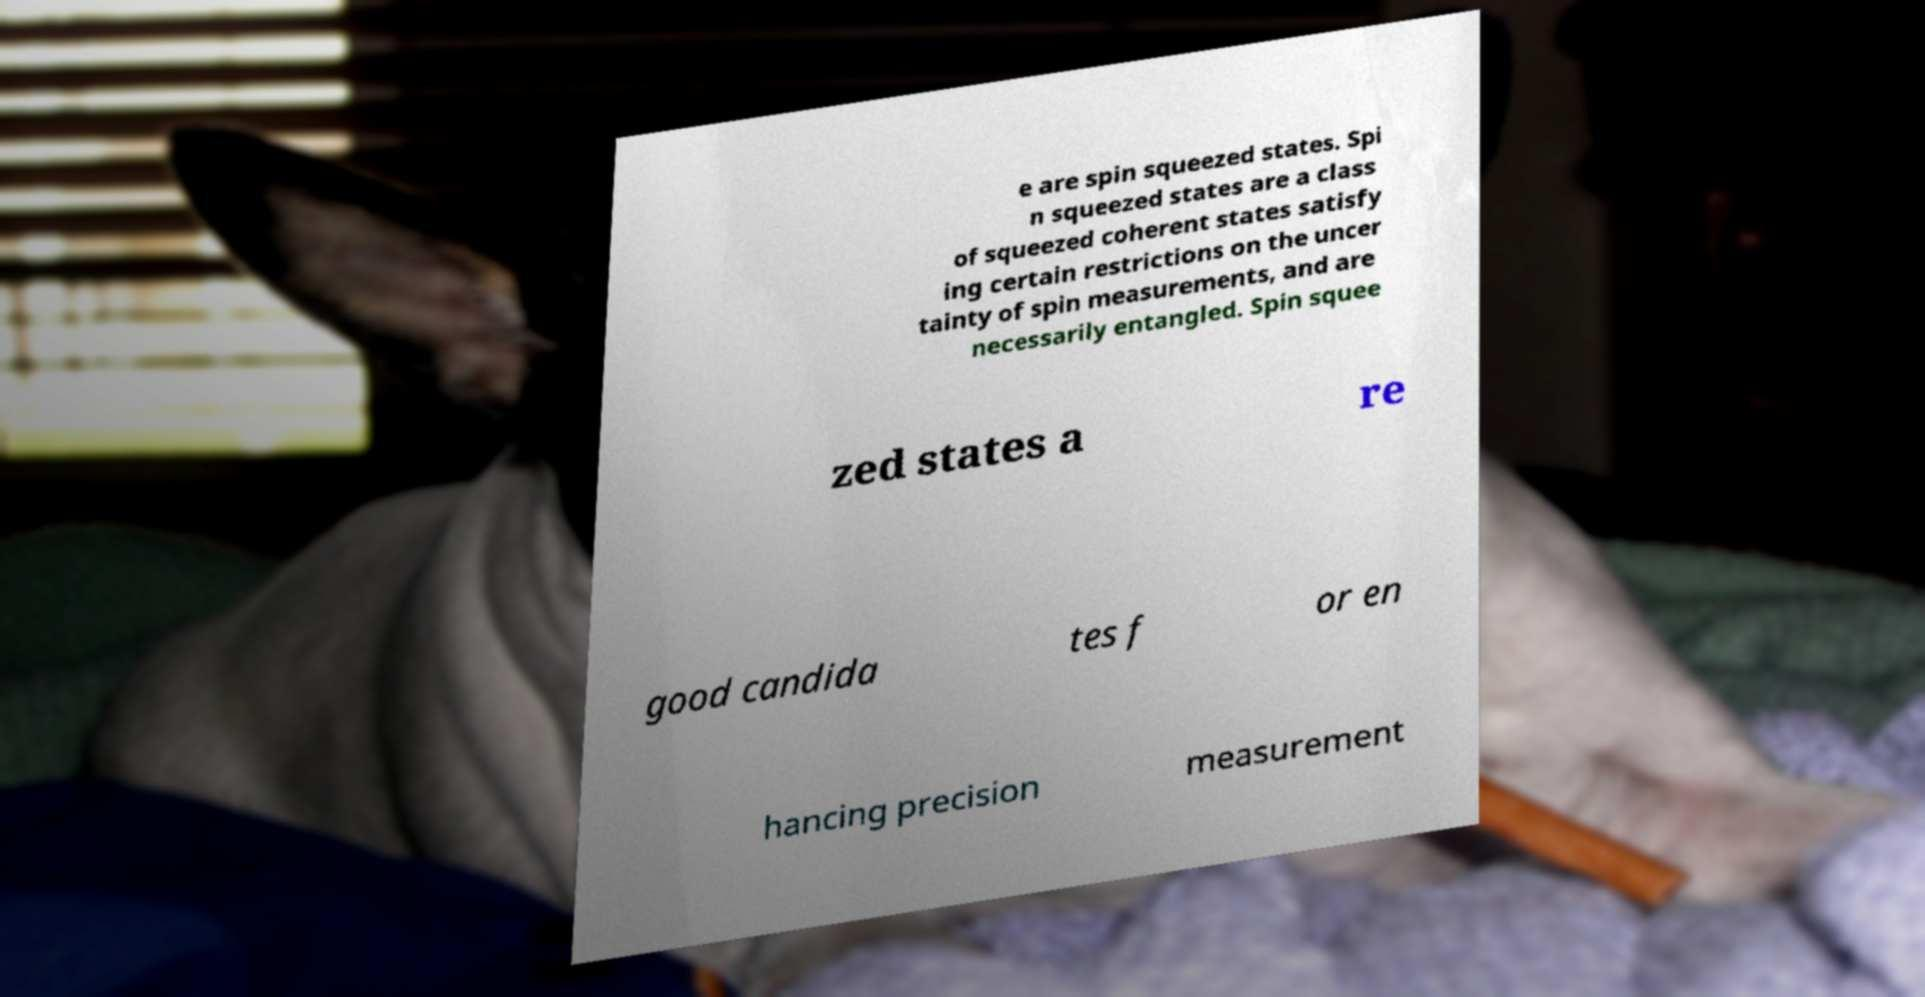Please read and relay the text visible in this image. What does it say? e are spin squeezed states. Spi n squeezed states are a class of squeezed coherent states satisfy ing certain restrictions on the uncer tainty of spin measurements, and are necessarily entangled. Spin squee zed states a re good candida tes f or en hancing precision measurement 